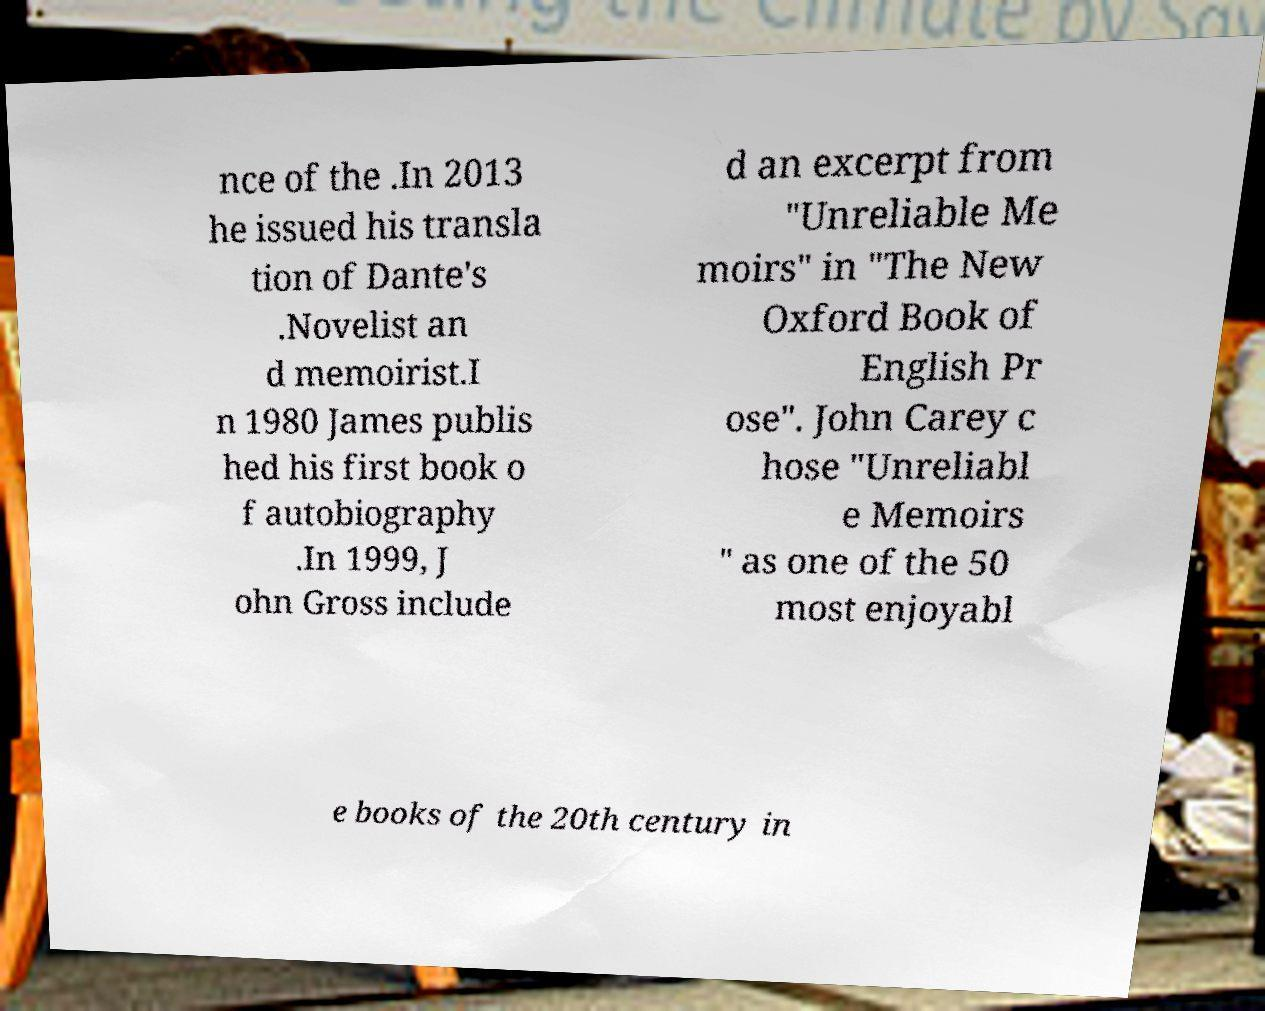There's text embedded in this image that I need extracted. Can you transcribe it verbatim? nce of the .In 2013 he issued his transla tion of Dante's .Novelist an d memoirist.I n 1980 James publis hed his first book o f autobiography .In 1999, J ohn Gross include d an excerpt from "Unreliable Me moirs" in "The New Oxford Book of English Pr ose". John Carey c hose "Unreliabl e Memoirs " as one of the 50 most enjoyabl e books of the 20th century in 